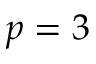Convert formula to latex. <formula><loc_0><loc_0><loc_500><loc_500>p = 3</formula> 